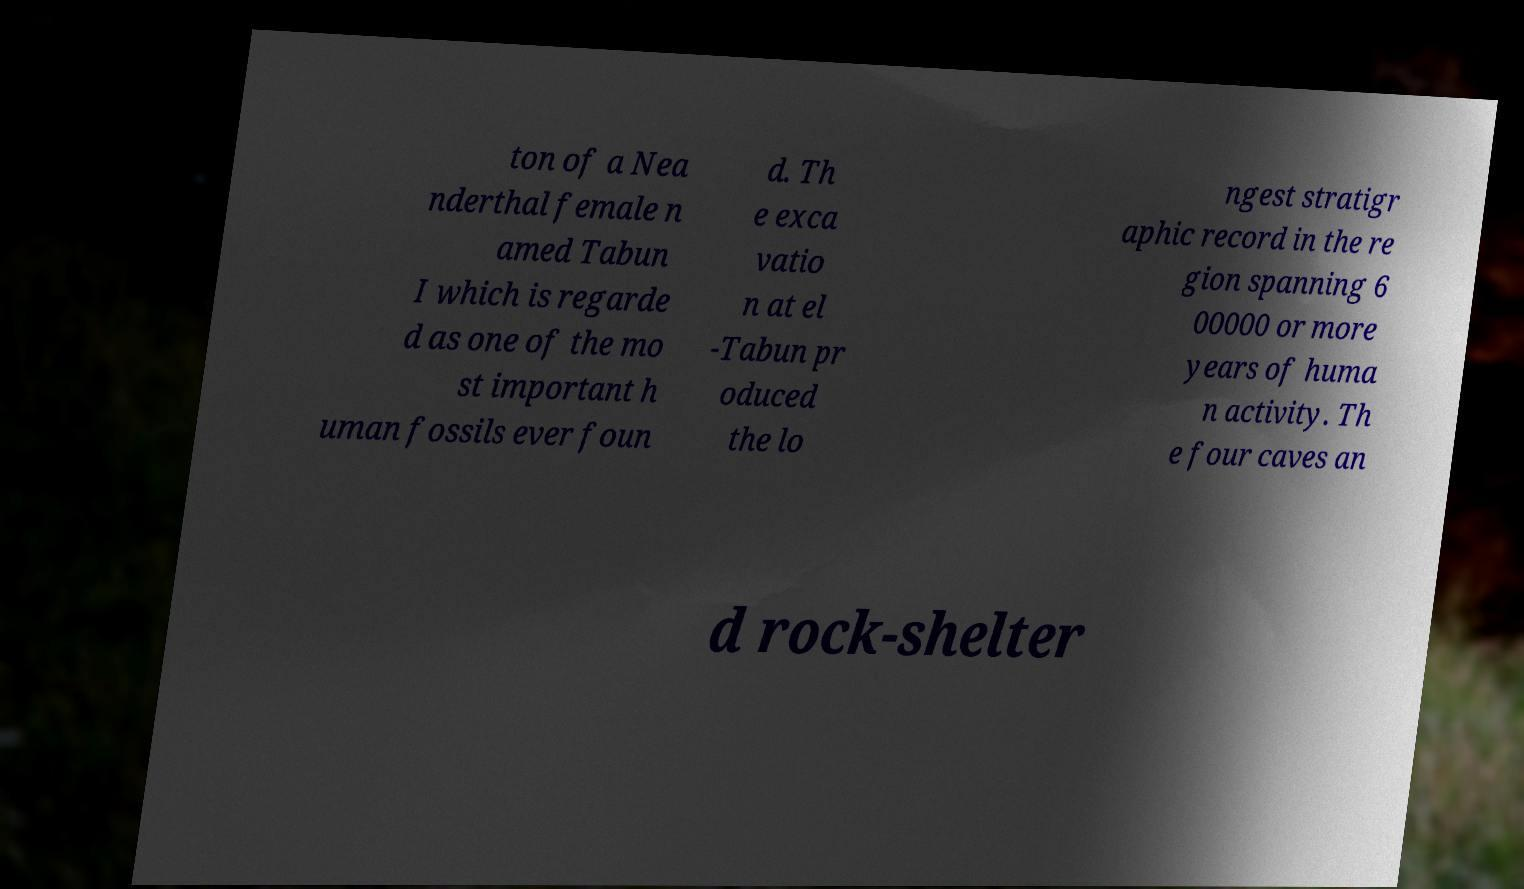There's text embedded in this image that I need extracted. Can you transcribe it verbatim? ton of a Nea nderthal female n amed Tabun I which is regarde d as one of the mo st important h uman fossils ever foun d. Th e exca vatio n at el -Tabun pr oduced the lo ngest stratigr aphic record in the re gion spanning 6 00000 or more years of huma n activity. Th e four caves an d rock-shelter 